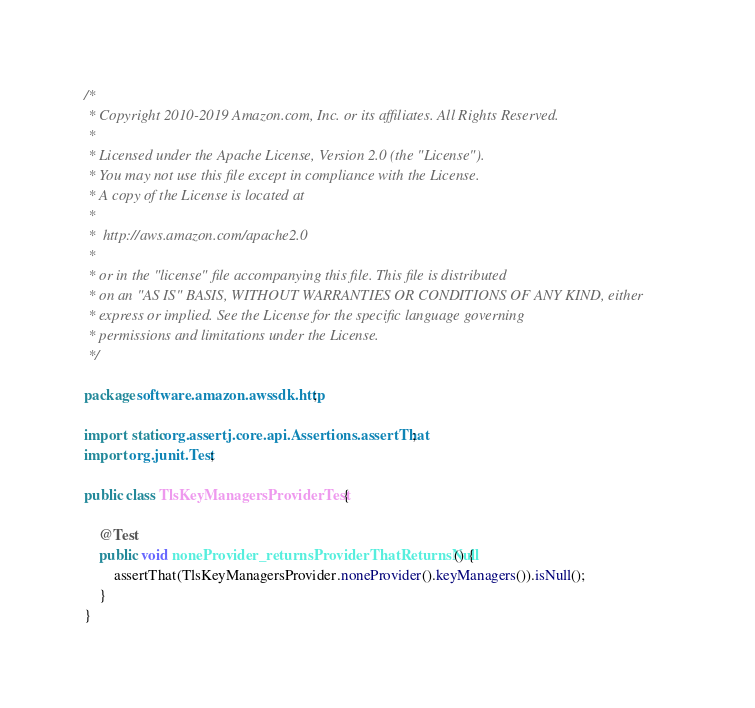Convert code to text. <code><loc_0><loc_0><loc_500><loc_500><_Java_>/*
 * Copyright 2010-2019 Amazon.com, Inc. or its affiliates. All Rights Reserved.
 *
 * Licensed under the Apache License, Version 2.0 (the "License").
 * You may not use this file except in compliance with the License.
 * A copy of the License is located at
 *
 *  http://aws.amazon.com/apache2.0
 *
 * or in the "license" file accompanying this file. This file is distributed
 * on an "AS IS" BASIS, WITHOUT WARRANTIES OR CONDITIONS OF ANY KIND, either
 * express or implied. See the License for the specific language governing
 * permissions and limitations under the License.
 */

package software.amazon.awssdk.http;

import static org.assertj.core.api.Assertions.assertThat;
import org.junit.Test;

public class TlsKeyManagersProviderTest {

    @Test
    public void noneProvider_returnsProviderThatReturnsNull() {
        assertThat(TlsKeyManagersProvider.noneProvider().keyManagers()).isNull();
    }
}
</code> 